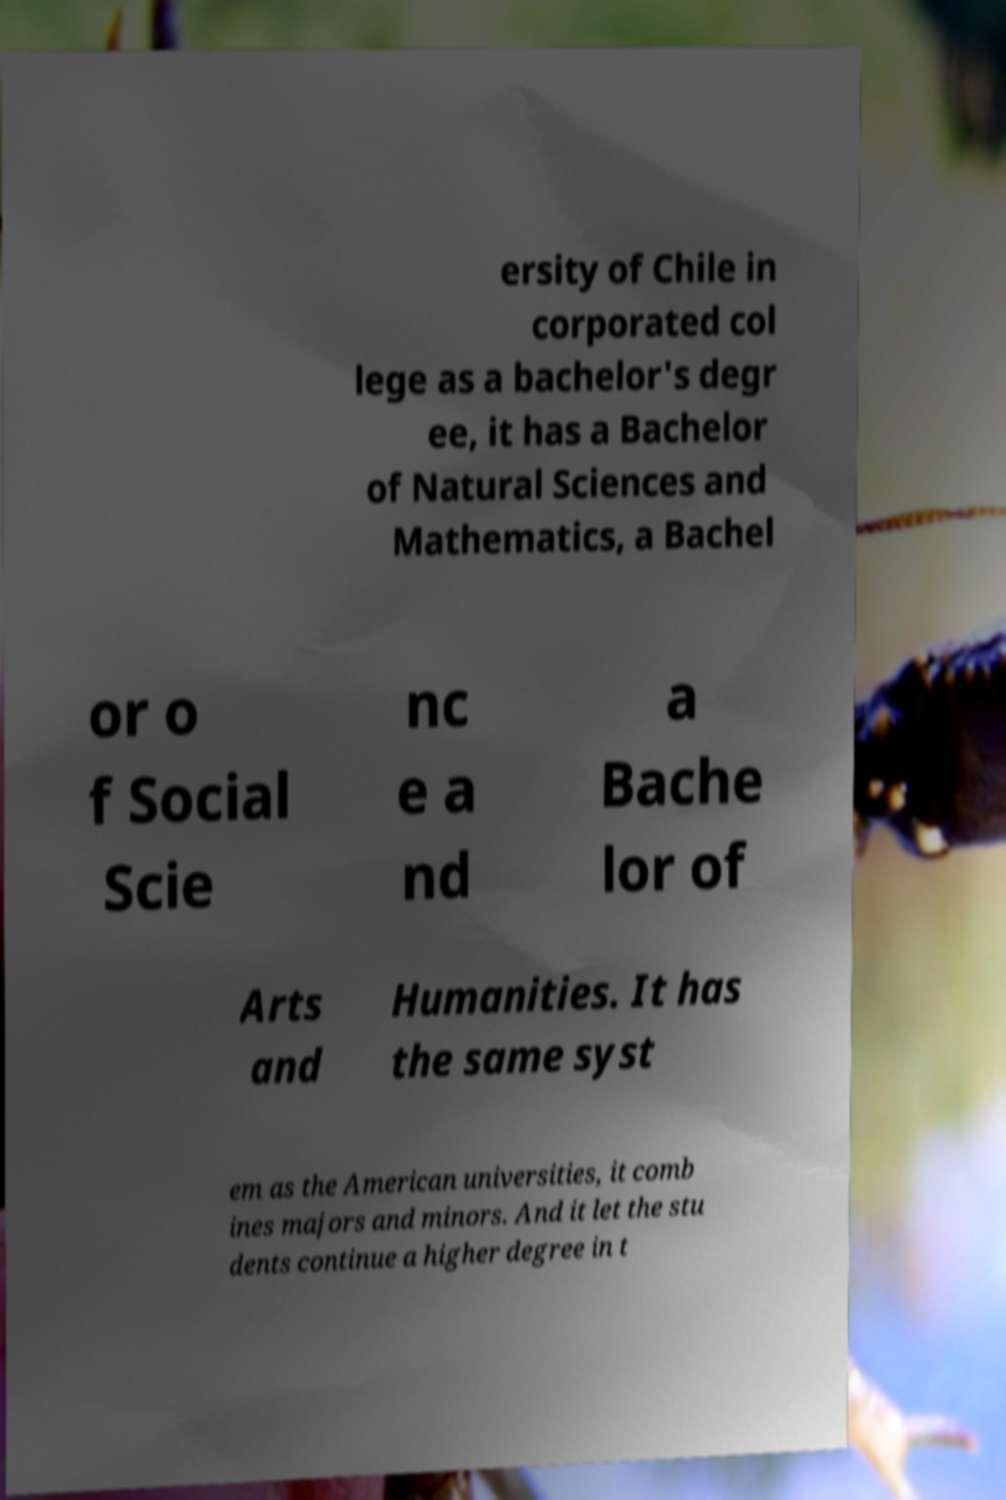Can you accurately transcribe the text from the provided image for me? ersity of Chile in corporated col lege as a bachelor's degr ee, it has a Bachelor of Natural Sciences and Mathematics, a Bachel or o f Social Scie nc e a nd a Bache lor of Arts and Humanities. It has the same syst em as the American universities, it comb ines majors and minors. And it let the stu dents continue a higher degree in t 